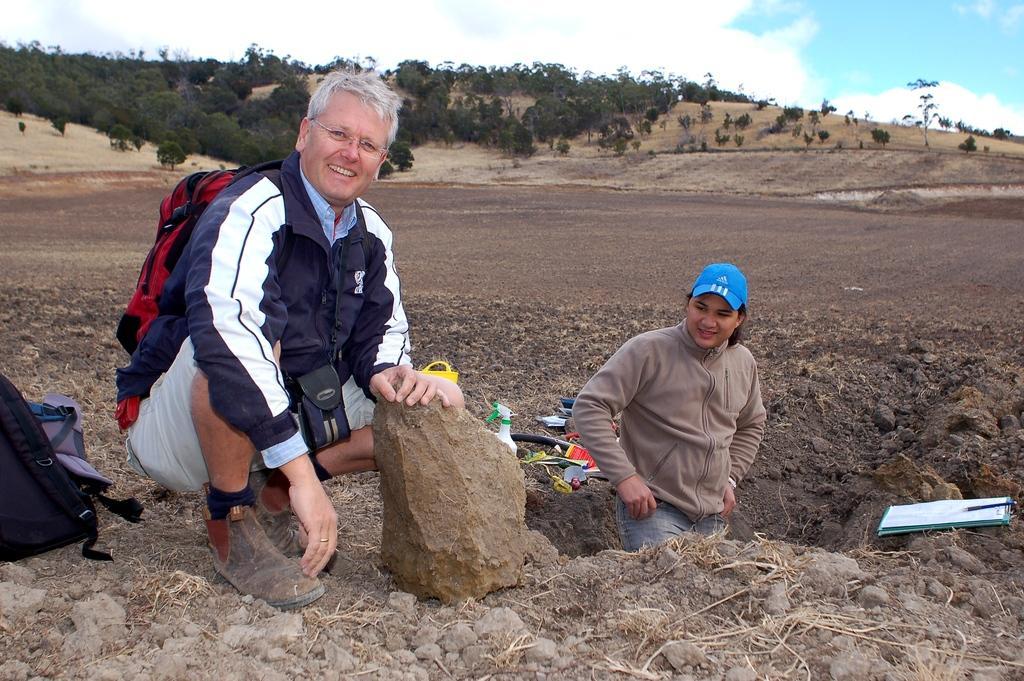How would you summarize this image in a sentence or two? In this image we can see two people among them one person is carrying bag, there are some objects on the ground, we can see some trees and plants, in the background we can see the sky. 